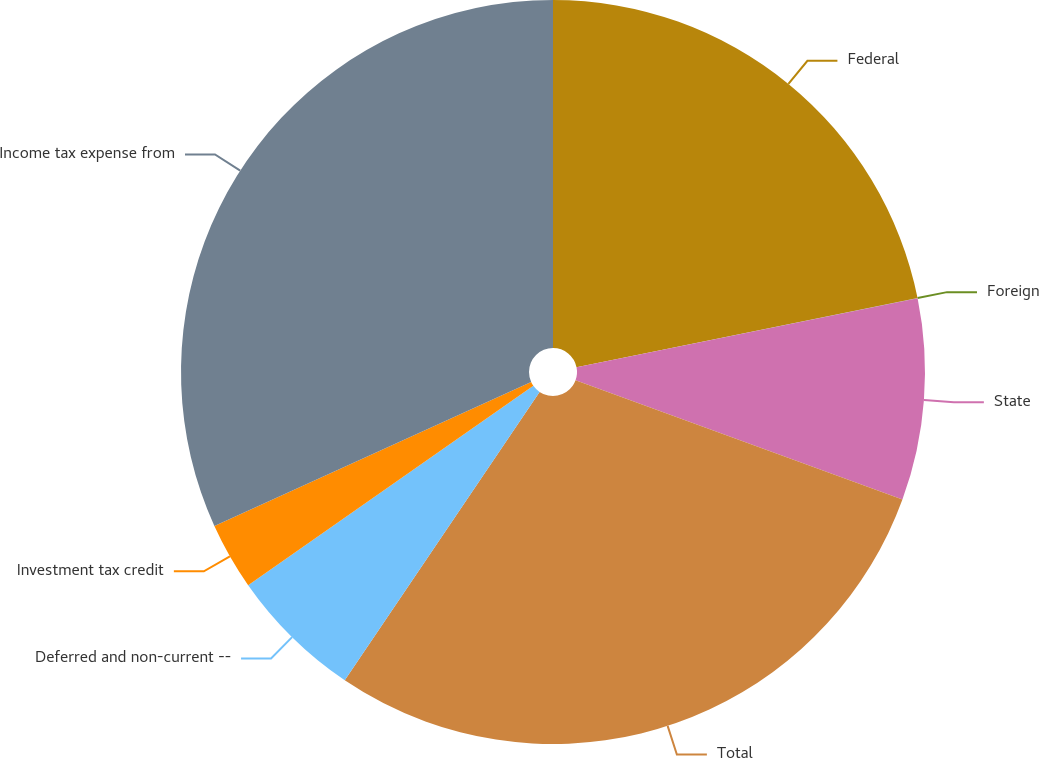<chart> <loc_0><loc_0><loc_500><loc_500><pie_chart><fcel>Federal<fcel>Foreign<fcel>State<fcel>Total<fcel>Deferred and non-current --<fcel>Investment tax credit<fcel>Income tax expense from<nl><fcel>21.81%<fcel>0.01%<fcel>8.75%<fcel>28.88%<fcel>5.83%<fcel>2.92%<fcel>31.79%<nl></chart> 